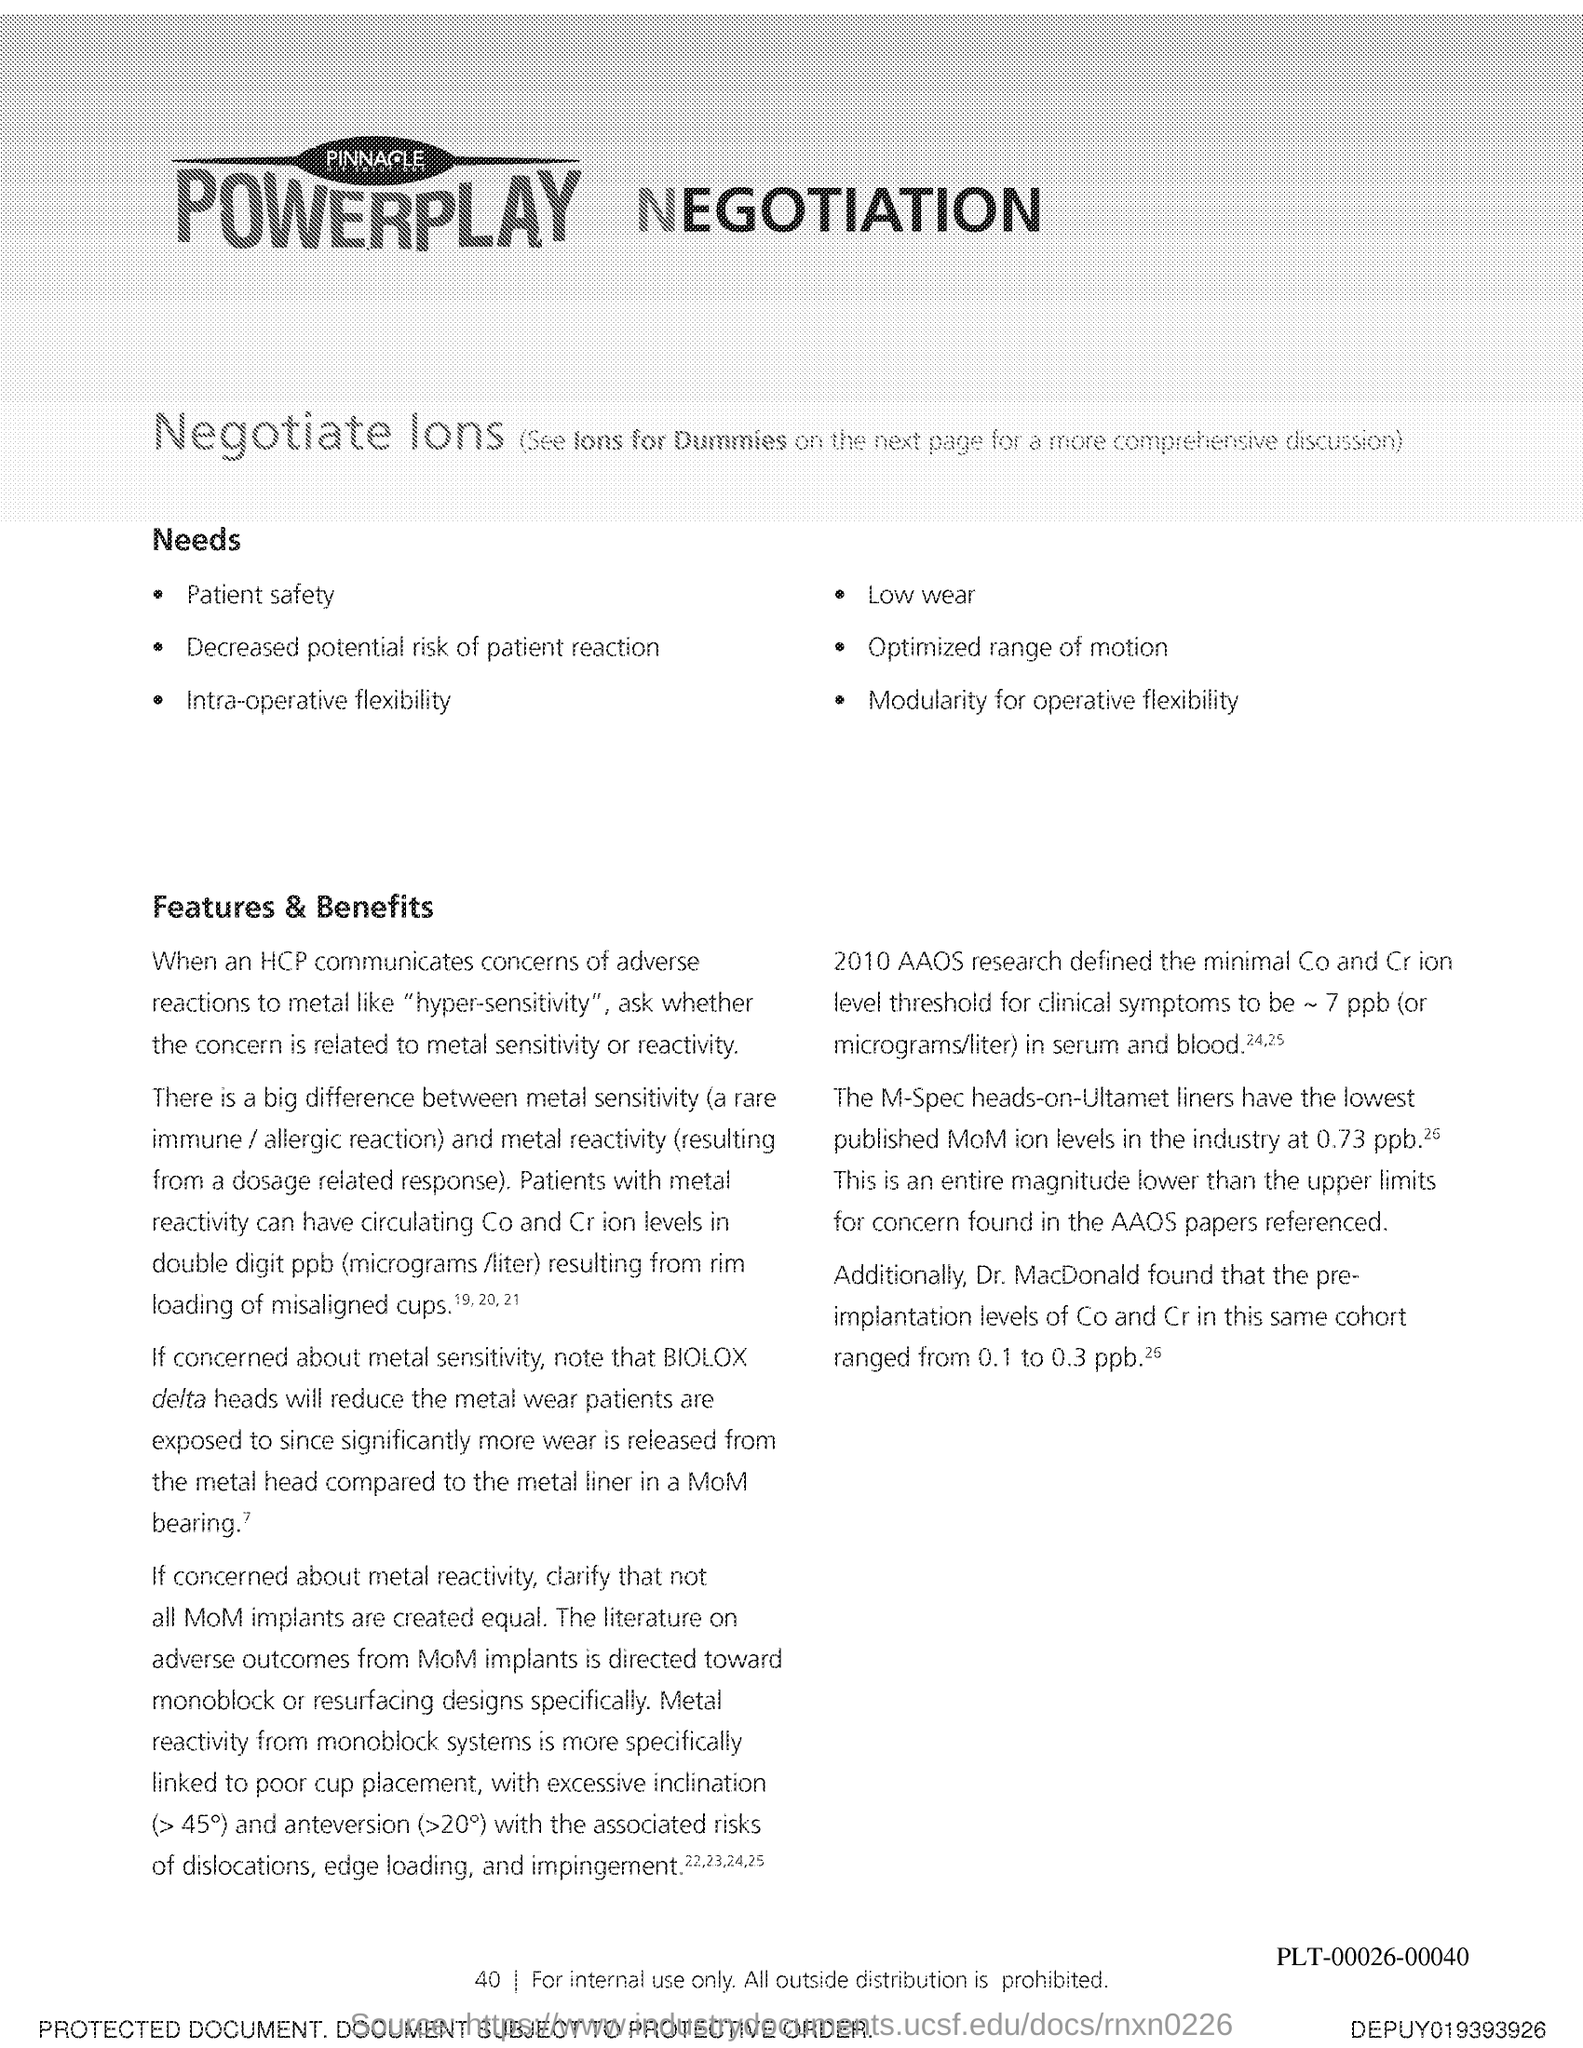Mention a couple of crucial points in this snapshot. Fourty is the page number. 